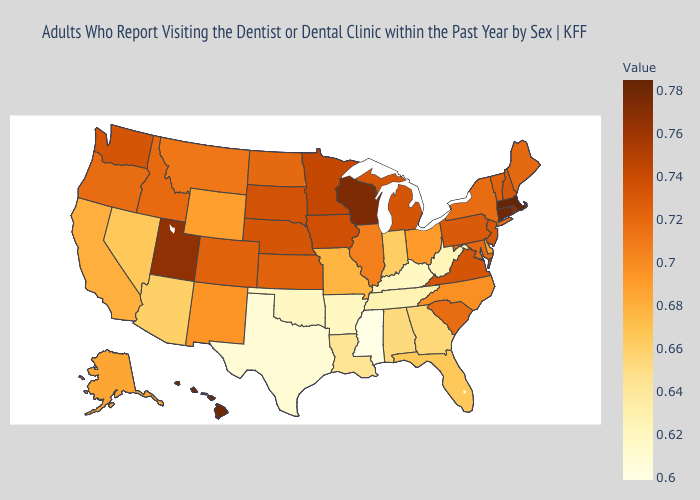Does South Dakota have the lowest value in the USA?
Concise answer only. No. Does Kansas have a higher value than Kentucky?
Short answer required. Yes. Does Illinois have the highest value in the MidWest?
Keep it brief. No. Among the states that border Pennsylvania , does New York have the highest value?
Answer briefly. No. 